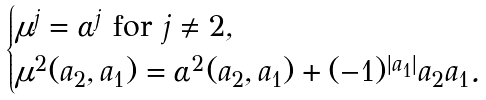<formula> <loc_0><loc_0><loc_500><loc_500>\begin{cases} \mu ^ { j } = \alpha ^ { j } \text { for $j \neq 2$} , \\ \mu ^ { 2 } ( a _ { 2 } , a _ { 1 } ) = \alpha ^ { 2 } ( a _ { 2 } , a _ { 1 } ) + ( - 1 ) ^ { | a _ { 1 } | } a _ { 2 } a _ { 1 } . \end{cases}</formula> 